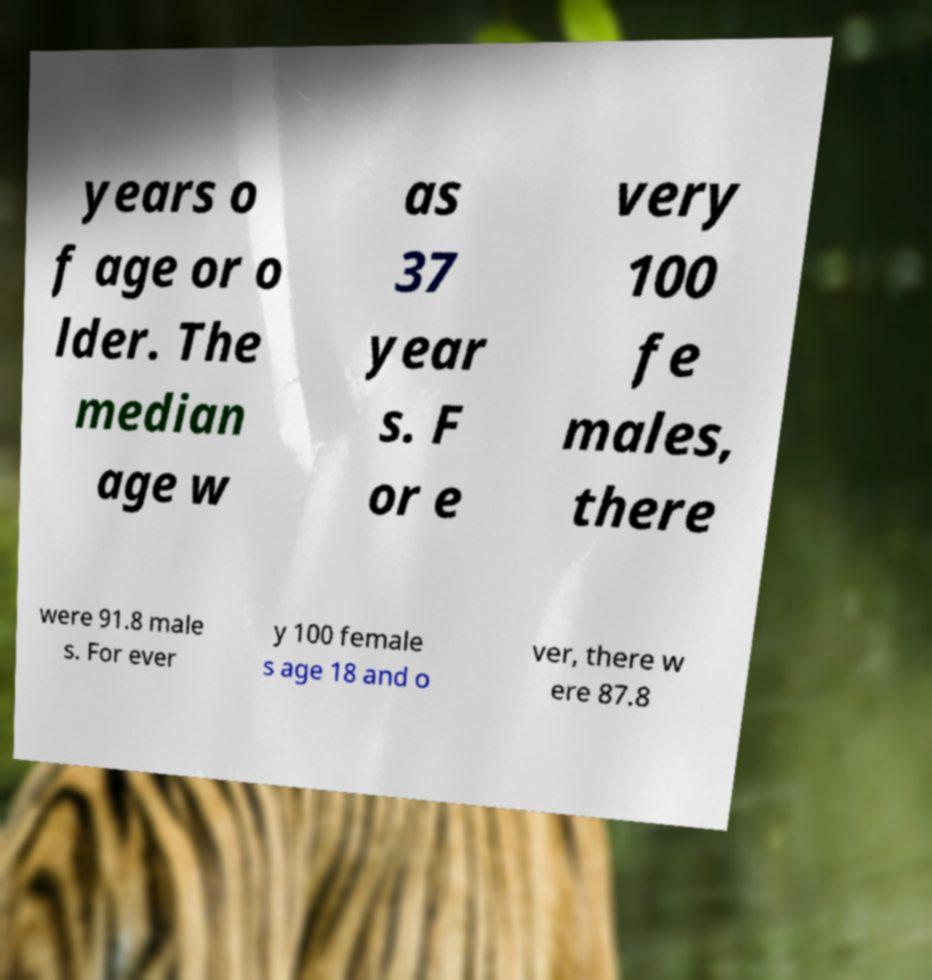Could you assist in decoding the text presented in this image and type it out clearly? years o f age or o lder. The median age w as 37 year s. F or e very 100 fe males, there were 91.8 male s. For ever y 100 female s age 18 and o ver, there w ere 87.8 